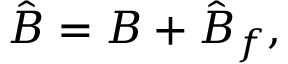Convert formula to latex. <formula><loc_0><loc_0><loc_500><loc_500>\hat { \boldsymbol B } = { \boldsymbol B } + \hat { \boldsymbol B } _ { f } ,</formula> 